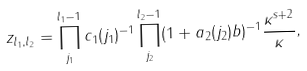<formula> <loc_0><loc_0><loc_500><loc_500>z _ { l _ { 1 } , l _ { 2 } } = \prod _ { j _ { 1 } } ^ { l _ { 1 } - 1 } c _ { 1 } ( j _ { 1 } ) ^ { - 1 } \prod _ { j _ { 2 } } ^ { l _ { 2 } - 1 } ( 1 + a _ { 2 } ( j _ { 2 } ) b ) ^ { - 1 } \frac { \kappa ^ { s + 2 } } { \kappa } ,</formula> 